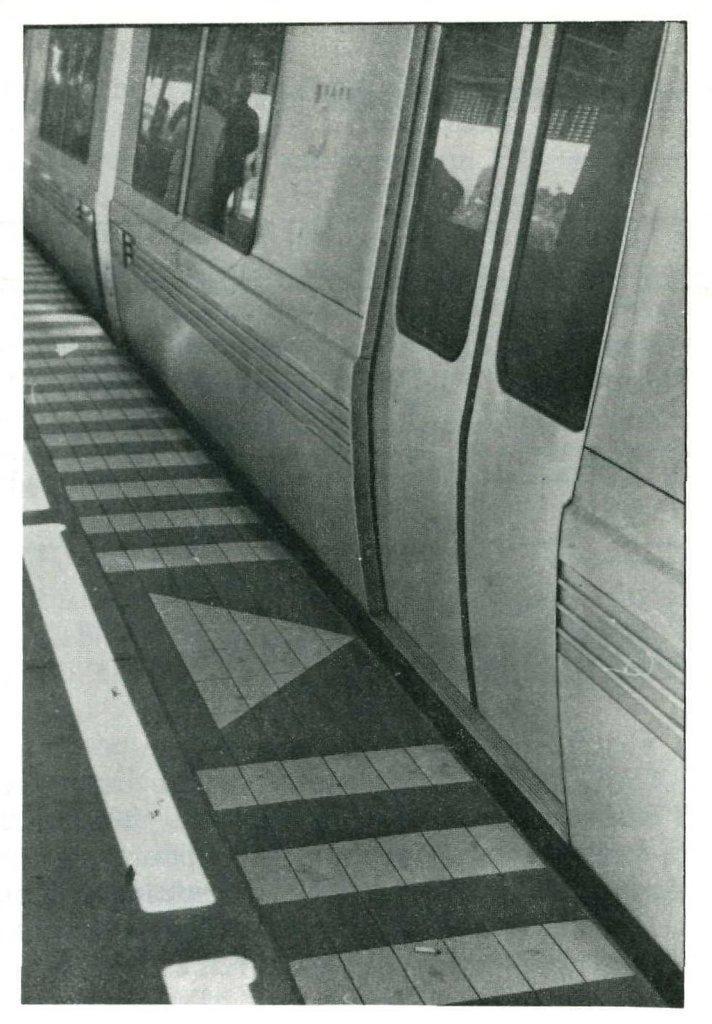Can you describe this image briefly? In this image we can see a door and windows of a train and a pathway. 